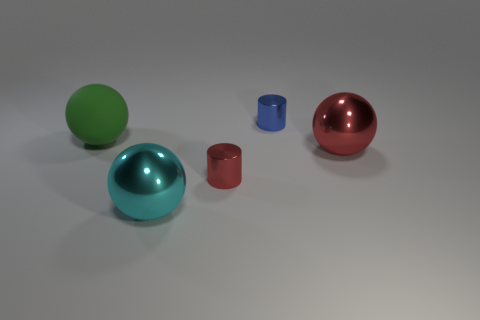Subtract all red shiny balls. How many balls are left? 2 Add 5 small green rubber spheres. How many objects exist? 10 Subtract all cyan spheres. How many spheres are left? 2 Subtract all spheres. How many objects are left? 2 Subtract all large green matte spheres. Subtract all blue metal objects. How many objects are left? 3 Add 3 tiny red metallic cylinders. How many tiny red metallic cylinders are left? 4 Add 2 big matte balls. How many big matte balls exist? 3 Subtract 0 brown cubes. How many objects are left? 5 Subtract 2 cylinders. How many cylinders are left? 0 Subtract all yellow balls. Subtract all gray cylinders. How many balls are left? 3 